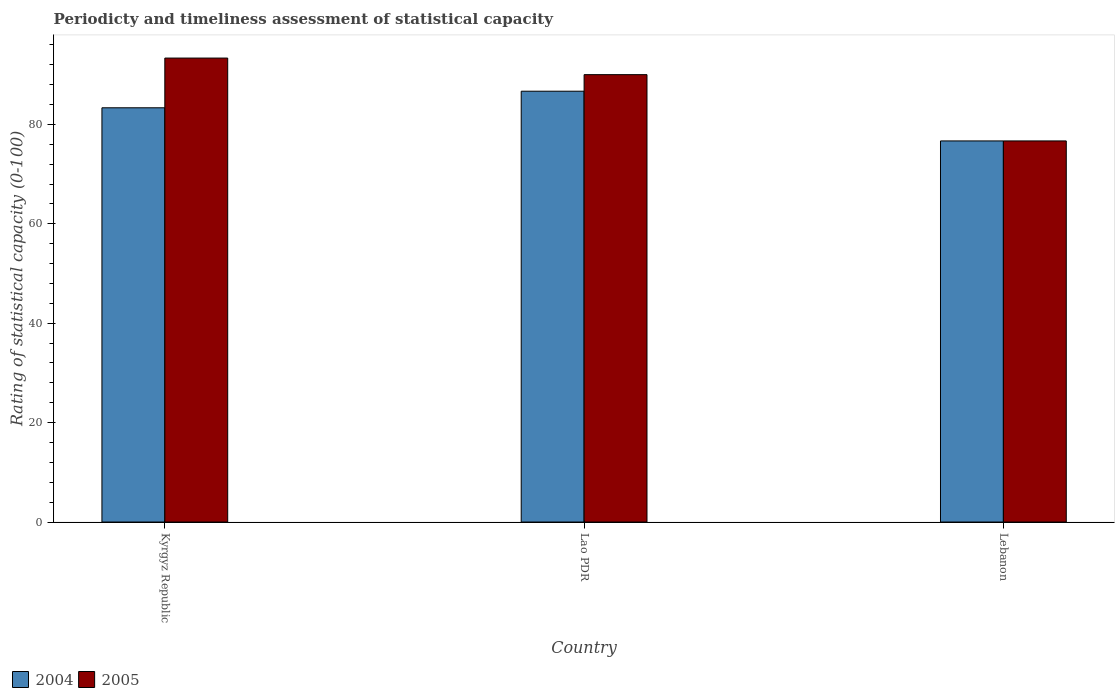Are the number of bars per tick equal to the number of legend labels?
Provide a succinct answer. Yes. Are the number of bars on each tick of the X-axis equal?
Keep it short and to the point. Yes. How many bars are there on the 1st tick from the left?
Ensure brevity in your answer.  2. What is the label of the 2nd group of bars from the left?
Your answer should be compact. Lao PDR. What is the rating of statistical capacity in 2005 in Lao PDR?
Give a very brief answer. 90. Across all countries, what is the maximum rating of statistical capacity in 2004?
Keep it short and to the point. 86.67. Across all countries, what is the minimum rating of statistical capacity in 2004?
Ensure brevity in your answer.  76.67. In which country was the rating of statistical capacity in 2004 maximum?
Provide a short and direct response. Lao PDR. In which country was the rating of statistical capacity in 2004 minimum?
Your answer should be very brief. Lebanon. What is the total rating of statistical capacity in 2004 in the graph?
Keep it short and to the point. 246.67. What is the difference between the rating of statistical capacity in 2005 in Kyrgyz Republic and that in Lao PDR?
Make the answer very short. 3.33. What is the difference between the rating of statistical capacity in 2004 in Lebanon and the rating of statistical capacity in 2005 in Lao PDR?
Your answer should be very brief. -13.33. What is the average rating of statistical capacity in 2004 per country?
Give a very brief answer. 82.22. In how many countries, is the rating of statistical capacity in 2004 greater than 76?
Keep it short and to the point. 3. What is the ratio of the rating of statistical capacity in 2005 in Lao PDR to that in Lebanon?
Make the answer very short. 1.17. Is the rating of statistical capacity in 2004 in Kyrgyz Republic less than that in Lebanon?
Make the answer very short. No. What is the difference between the highest and the second highest rating of statistical capacity in 2004?
Your answer should be compact. 6.67. In how many countries, is the rating of statistical capacity in 2005 greater than the average rating of statistical capacity in 2005 taken over all countries?
Offer a terse response. 2. Is the sum of the rating of statistical capacity in 2005 in Kyrgyz Republic and Lebanon greater than the maximum rating of statistical capacity in 2004 across all countries?
Give a very brief answer. Yes. What does the 2nd bar from the left in Lebanon represents?
Make the answer very short. 2005. What does the 2nd bar from the right in Lao PDR represents?
Offer a very short reply. 2004. How many countries are there in the graph?
Your answer should be very brief. 3. What is the difference between two consecutive major ticks on the Y-axis?
Your answer should be very brief. 20. Does the graph contain grids?
Keep it short and to the point. No. Where does the legend appear in the graph?
Offer a terse response. Bottom left. How are the legend labels stacked?
Your response must be concise. Horizontal. What is the title of the graph?
Offer a terse response. Periodicty and timeliness assessment of statistical capacity. Does "2000" appear as one of the legend labels in the graph?
Provide a short and direct response. No. What is the label or title of the X-axis?
Keep it short and to the point. Country. What is the label or title of the Y-axis?
Your response must be concise. Rating of statistical capacity (0-100). What is the Rating of statistical capacity (0-100) in 2004 in Kyrgyz Republic?
Your response must be concise. 83.33. What is the Rating of statistical capacity (0-100) in 2005 in Kyrgyz Republic?
Ensure brevity in your answer.  93.33. What is the Rating of statistical capacity (0-100) in 2004 in Lao PDR?
Offer a terse response. 86.67. What is the Rating of statistical capacity (0-100) of 2005 in Lao PDR?
Keep it short and to the point. 90. What is the Rating of statistical capacity (0-100) of 2004 in Lebanon?
Ensure brevity in your answer.  76.67. What is the Rating of statistical capacity (0-100) in 2005 in Lebanon?
Make the answer very short. 76.67. Across all countries, what is the maximum Rating of statistical capacity (0-100) in 2004?
Your response must be concise. 86.67. Across all countries, what is the maximum Rating of statistical capacity (0-100) of 2005?
Ensure brevity in your answer.  93.33. Across all countries, what is the minimum Rating of statistical capacity (0-100) in 2004?
Provide a succinct answer. 76.67. Across all countries, what is the minimum Rating of statistical capacity (0-100) in 2005?
Your answer should be compact. 76.67. What is the total Rating of statistical capacity (0-100) in 2004 in the graph?
Your response must be concise. 246.67. What is the total Rating of statistical capacity (0-100) of 2005 in the graph?
Offer a very short reply. 260. What is the difference between the Rating of statistical capacity (0-100) in 2005 in Kyrgyz Republic and that in Lao PDR?
Give a very brief answer. 3.33. What is the difference between the Rating of statistical capacity (0-100) of 2004 in Kyrgyz Republic and that in Lebanon?
Offer a terse response. 6.67. What is the difference between the Rating of statistical capacity (0-100) in 2005 in Kyrgyz Republic and that in Lebanon?
Offer a terse response. 16.67. What is the difference between the Rating of statistical capacity (0-100) in 2004 in Lao PDR and that in Lebanon?
Your answer should be compact. 10. What is the difference between the Rating of statistical capacity (0-100) of 2005 in Lao PDR and that in Lebanon?
Provide a short and direct response. 13.33. What is the difference between the Rating of statistical capacity (0-100) in 2004 in Kyrgyz Republic and the Rating of statistical capacity (0-100) in 2005 in Lao PDR?
Offer a terse response. -6.67. What is the difference between the Rating of statistical capacity (0-100) in 2004 in Kyrgyz Republic and the Rating of statistical capacity (0-100) in 2005 in Lebanon?
Offer a very short reply. 6.67. What is the difference between the Rating of statistical capacity (0-100) in 2004 in Lao PDR and the Rating of statistical capacity (0-100) in 2005 in Lebanon?
Offer a terse response. 10. What is the average Rating of statistical capacity (0-100) of 2004 per country?
Provide a short and direct response. 82.22. What is the average Rating of statistical capacity (0-100) of 2005 per country?
Ensure brevity in your answer.  86.67. What is the difference between the Rating of statistical capacity (0-100) in 2004 and Rating of statistical capacity (0-100) in 2005 in Lao PDR?
Your response must be concise. -3.33. What is the difference between the Rating of statistical capacity (0-100) of 2004 and Rating of statistical capacity (0-100) of 2005 in Lebanon?
Make the answer very short. 0. What is the ratio of the Rating of statistical capacity (0-100) in 2004 in Kyrgyz Republic to that in Lao PDR?
Make the answer very short. 0.96. What is the ratio of the Rating of statistical capacity (0-100) in 2005 in Kyrgyz Republic to that in Lao PDR?
Offer a terse response. 1.04. What is the ratio of the Rating of statistical capacity (0-100) in 2004 in Kyrgyz Republic to that in Lebanon?
Your answer should be compact. 1.09. What is the ratio of the Rating of statistical capacity (0-100) in 2005 in Kyrgyz Republic to that in Lebanon?
Offer a very short reply. 1.22. What is the ratio of the Rating of statistical capacity (0-100) in 2004 in Lao PDR to that in Lebanon?
Your answer should be very brief. 1.13. What is the ratio of the Rating of statistical capacity (0-100) of 2005 in Lao PDR to that in Lebanon?
Ensure brevity in your answer.  1.17. What is the difference between the highest and the second highest Rating of statistical capacity (0-100) in 2004?
Your answer should be compact. 3.33. What is the difference between the highest and the second highest Rating of statistical capacity (0-100) in 2005?
Provide a succinct answer. 3.33. What is the difference between the highest and the lowest Rating of statistical capacity (0-100) of 2005?
Provide a succinct answer. 16.67. 